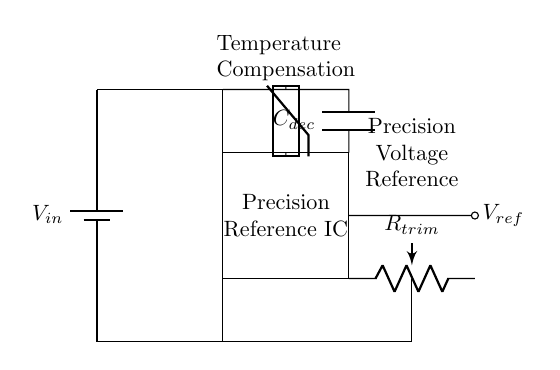What is the input voltage of this circuit? The input voltage is denoted as \( V_{in} \), which is connected to the positive terminal of the battery. The diagram doesn't specify its value, but it indicates that the circuit is powered by this voltage source.
Answer: \( V_{in} \) What is the role of the precision reference IC? The precision reference IC is shown as a rectangle in the circuit diagram. It is responsible for providing a stable reference voltage output. In this context, it allows for high-accuracy calibration of instruments by ensuring a constant voltage value.
Answer: Stable reference voltage What is the purpose of the trim potentiometer \( R_{trim} \)? The trim potentiometer is used for fine-tuning the output voltage of the precision reference IC, allowing for calibration adjustments to improve accuracy. It is linked to the voltage reference, indicating its role in adjusting the output as needed.
Answer: Calibration adjustment What is the output voltage called in this circuit? The output voltage is referred to as \( V_{ref} \), which signifies the reference voltage provided to the measurement instruments, ensuring accuracy in readings. It is clearly labeled next to the output connection in the diagram.
Answer: \( V_{ref} \) How does temperature compensation work in this circuit? Temperature compensation is provided by the thermistor in the circuit, which adjusts the output voltage based on temperature variations. It is connected to the precision reference IC, showing its role in maintaining output stability under different thermal conditions, ensuring precise measurements.
Answer: Thermistor adjustment What component provides decoupling in this circuit? The decoupling capacitor \( C_{dec} \) is shown in the circuit, designed to filter out noise from the input voltage supply, ensuring that the reference IC gets a stable voltage for consistent performance. Its placement is crucial for maintaining voltage integrity.
Answer: \( C_{dec} \) What connection is used for the temperature sensor in the circuit? The temperature sensor is connected to the top of the precision reference IC. This implementation allows the output voltage to be dynamically adjusted based on the temperature readings, increasing the overall stability and precision of the calibration circuit.
Answer: Top connection 